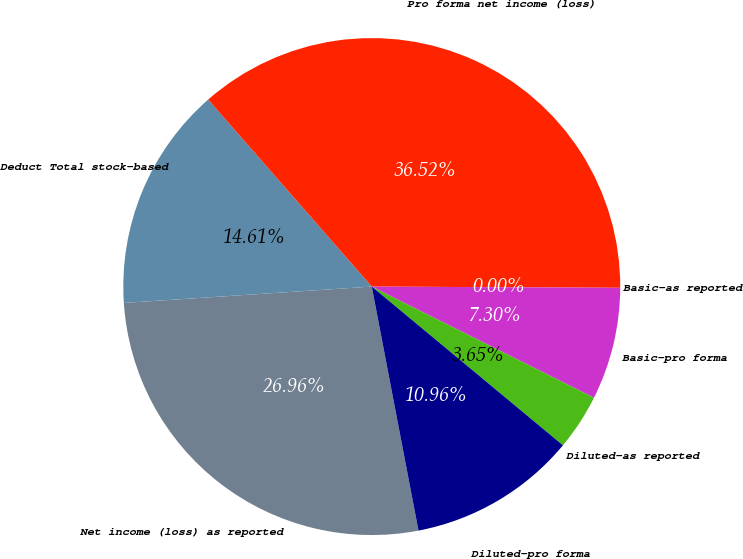Convert chart to OTSL. <chart><loc_0><loc_0><loc_500><loc_500><pie_chart><fcel>Net income (loss) as reported<fcel>Deduct Total stock-based<fcel>Pro forma net income (loss)<fcel>Basic-as reported<fcel>Basic-pro forma<fcel>Diluted-as reported<fcel>Diluted-pro forma<nl><fcel>26.96%<fcel>14.61%<fcel>36.52%<fcel>0.0%<fcel>7.3%<fcel>3.65%<fcel>10.96%<nl></chart> 